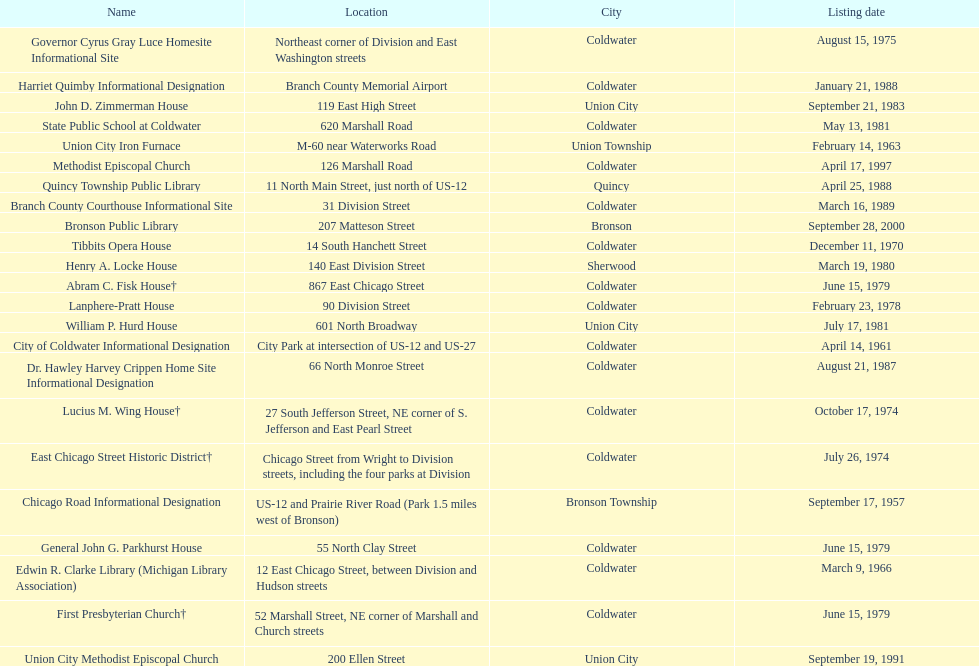How many sites are in coldwater? 15. 